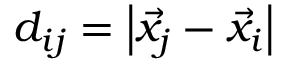Convert formula to latex. <formula><loc_0><loc_0><loc_500><loc_500>d _ { i j } = \left | \vec { x } _ { j } - \vec { x } _ { i } \right |</formula> 